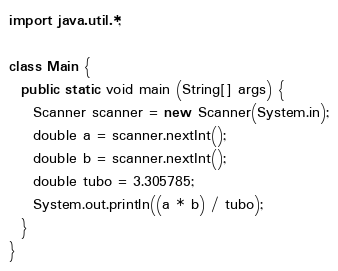<code> <loc_0><loc_0><loc_500><loc_500><_Java_>import java.util.*;

class Main {
  public static void main (String[] args) {
    Scanner scanner = new Scanner(System.in);
    double a = scanner.nextInt();
    double b = scanner.nextInt();
    double tubo = 3.305785;
    System.out.println((a * b) / tubo);
  }
}</code> 